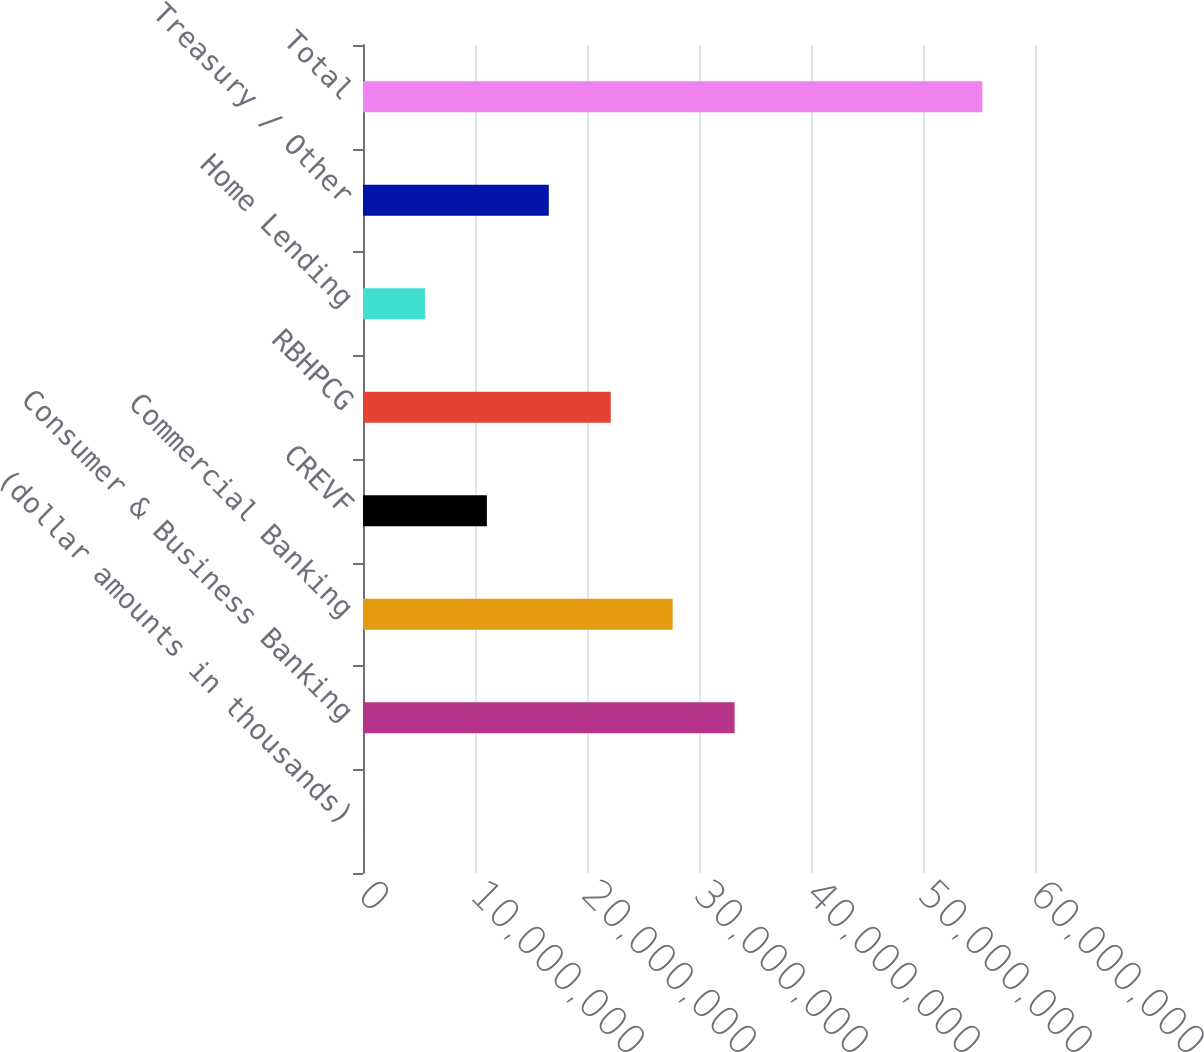Convert chart to OTSL. <chart><loc_0><loc_0><loc_500><loc_500><bar_chart><fcel>(dollar amounts in thousands)<fcel>Consumer & Business Banking<fcel>Commercial Banking<fcel>CREVF<fcel>RBHPCG<fcel>Home Lending<fcel>Treasury / Other<fcel>Total<nl><fcel>2015<fcel>3.31778e+07<fcel>2.76485e+07<fcel>1.10606e+07<fcel>2.21192e+07<fcel>5.53131e+06<fcel>1.65899e+07<fcel>5.5295e+07<nl></chart> 